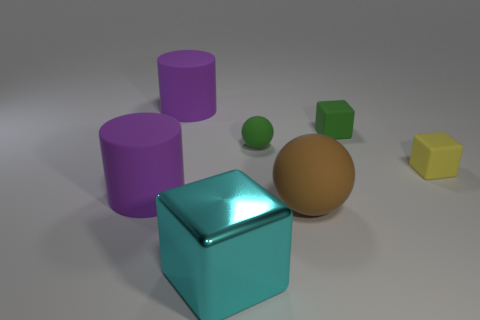Add 3 red rubber cylinders. How many objects exist? 10 Subtract all cylinders. How many objects are left? 5 Add 4 big cyan metallic blocks. How many big cyan metallic blocks exist? 5 Subtract 0 cyan balls. How many objects are left? 7 Subtract all large cyan rubber cylinders. Subtract all green things. How many objects are left? 5 Add 7 big metallic blocks. How many big metallic blocks are left? 8 